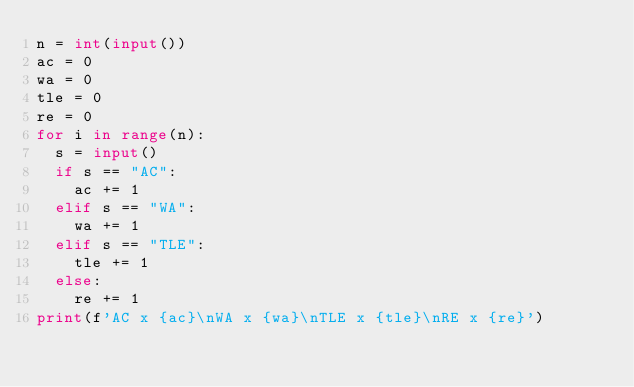<code> <loc_0><loc_0><loc_500><loc_500><_Python_>n = int(input())
ac = 0
wa = 0
tle = 0
re = 0
for i in range(n):
  s = input()
  if s == "AC":
    ac += 1
  elif s == "WA":
    wa += 1
  elif s == "TLE":
    tle += 1
  else:
    re += 1
print(f'AC x {ac}\nWA x {wa}\nTLE x {tle}\nRE x {re}')</code> 